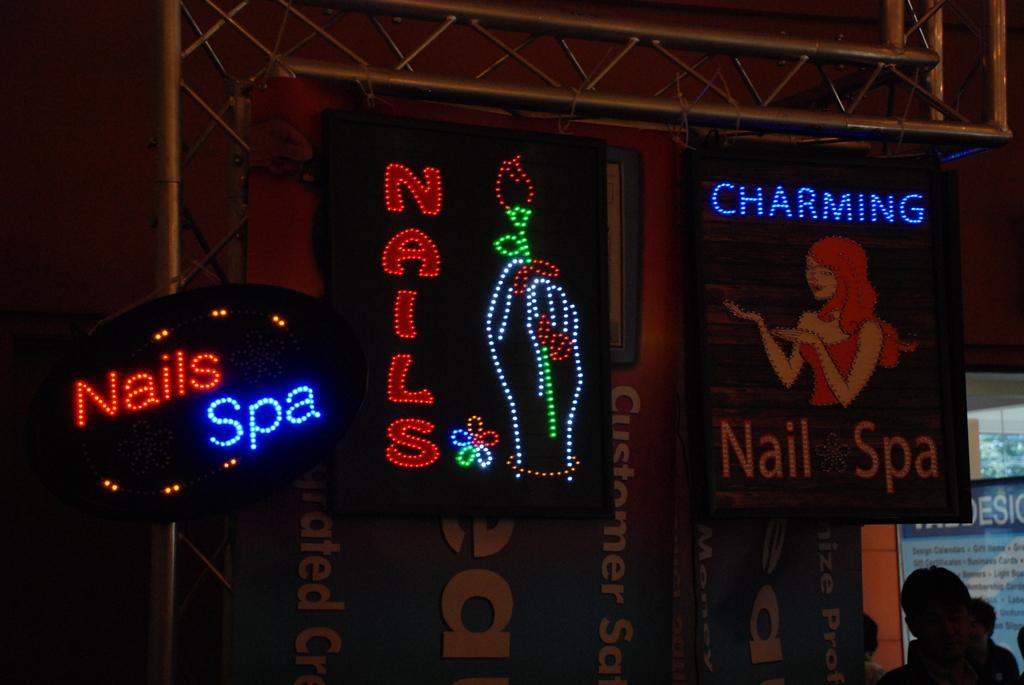Can you describe this image briefly? In this image I can see number of boards and on it I can see something is written. I can also see lights on few boards and on the bottom right side of this image I can see few people. In the background I can see few poles and I can also see this image is little bit in dark. 